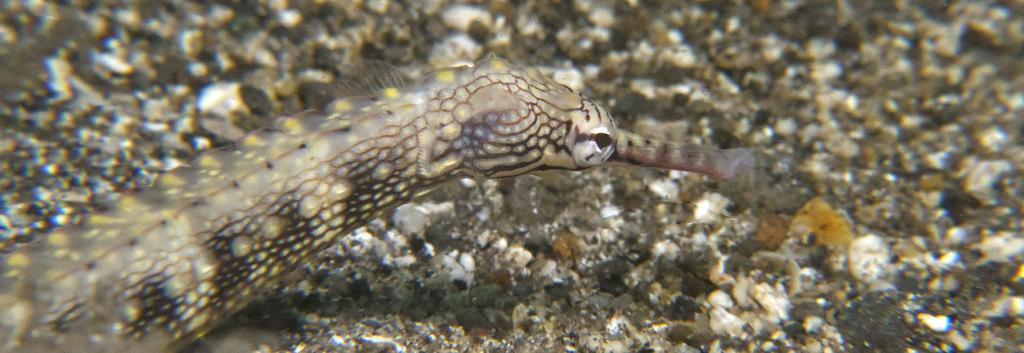What type of animal is in the image? There is a reptile in the image, which appears to be a snake. On which side of the image is the snake located? The snake is on the left side of the image. What can be seen in the background of the image? There are gravels visible in the background of the image. What type of instrument is being played by the snake in the image? There is no instrument being played in the image, as the snake is not depicted as playing any instrument. 